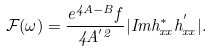Convert formula to latex. <formula><loc_0><loc_0><loc_500><loc_500>\mathcal { F } ( \omega ) = \frac { e ^ { 4 A - B } f } { 4 A ^ { ^ { \prime } 2 } } | I m h _ { x x } ^ { * } h _ { x x } ^ { ^ { \prime } } | .</formula> 